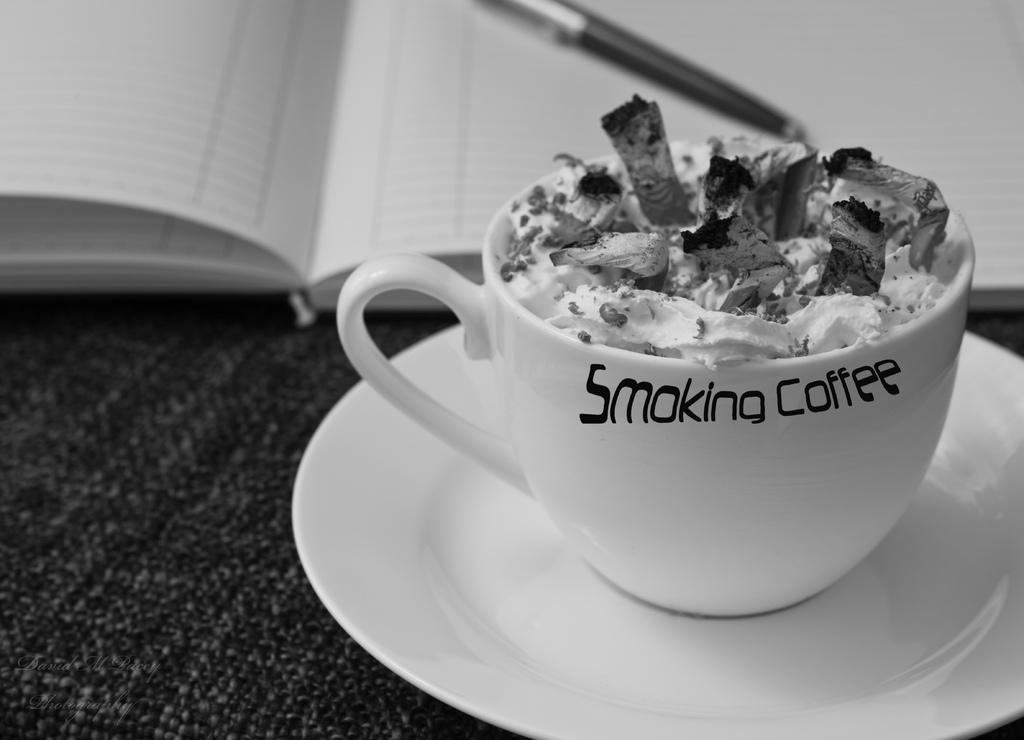What type of dessert is visible in the image? There is an ice-cream in a cup in the image. What other objects can be seen in the image? There is a pen on a book in the image. What type of liquid is being used to destroy the book in the image? There is no liquid or destruction present in the image; it only shows an ice-cream in a cup and a pen on a book. 